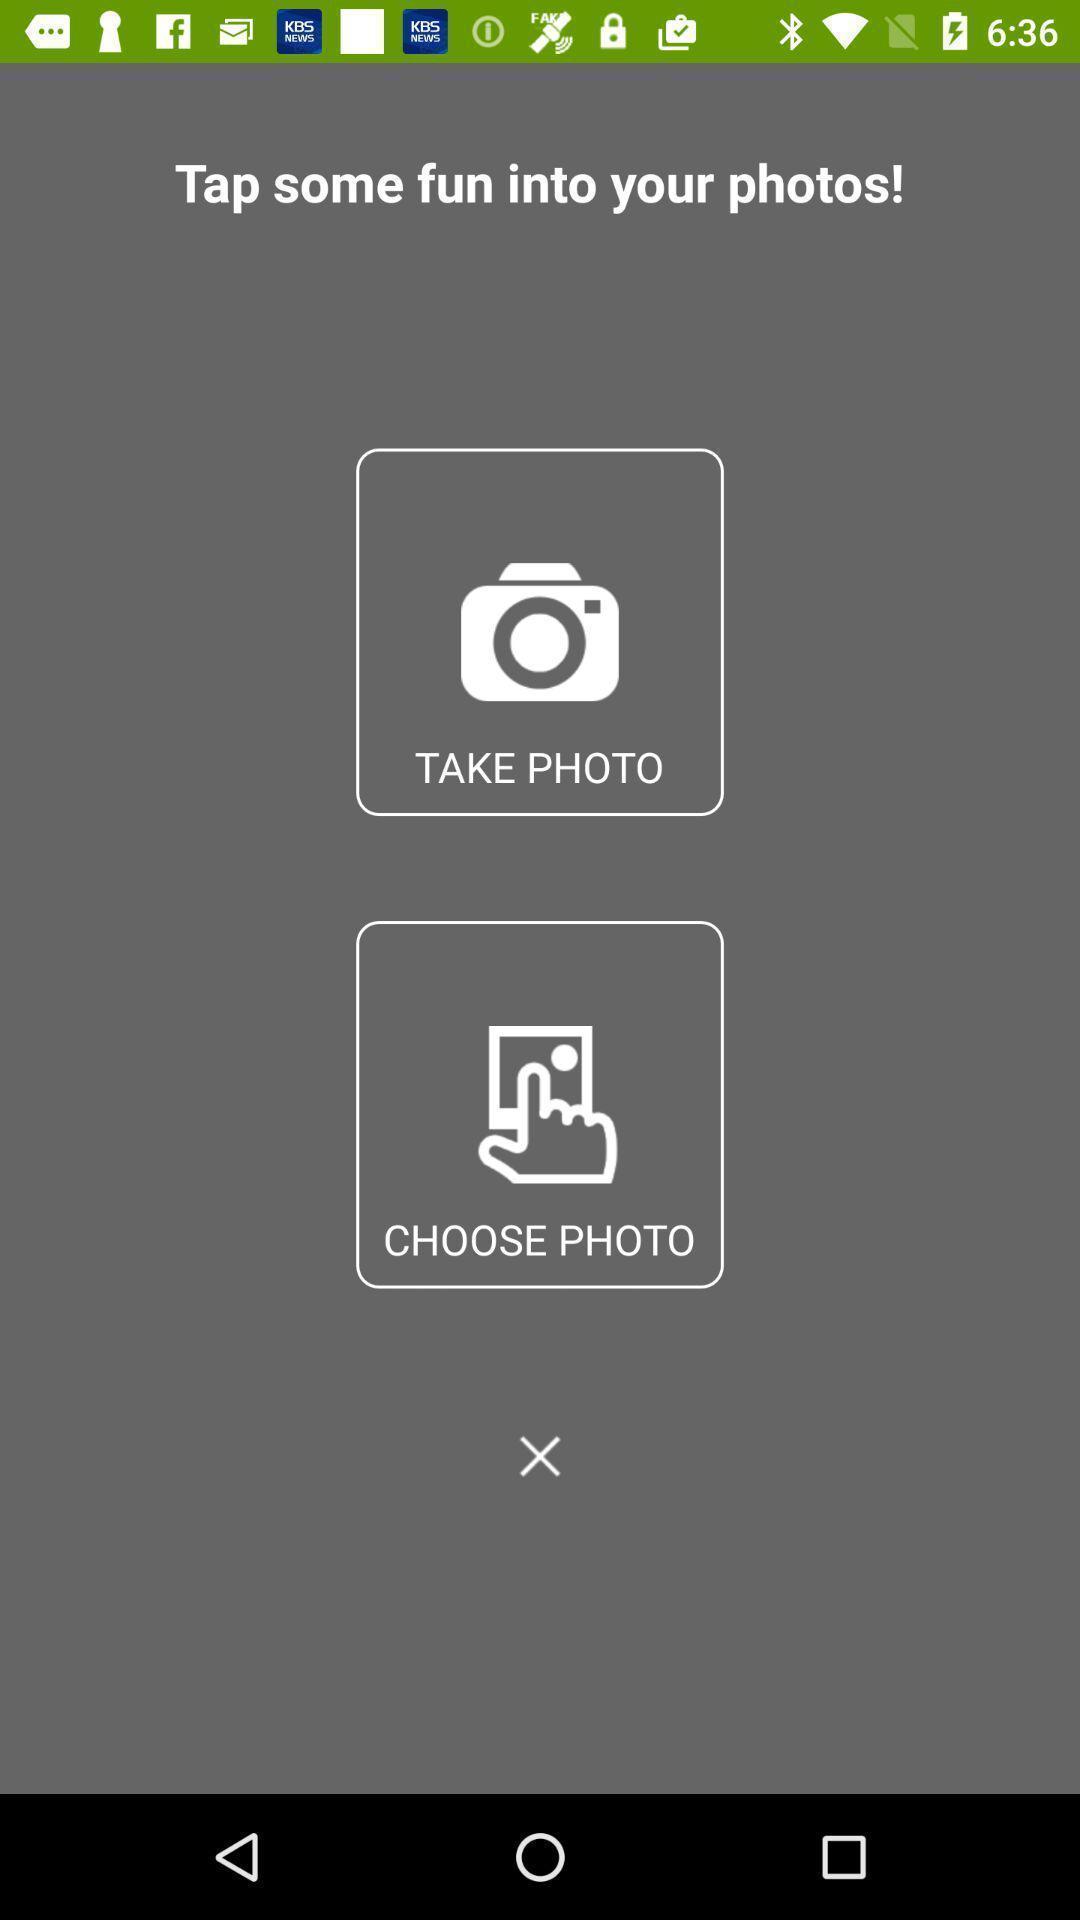Describe the visual elements of this screenshot. Page displaying the photo options. 